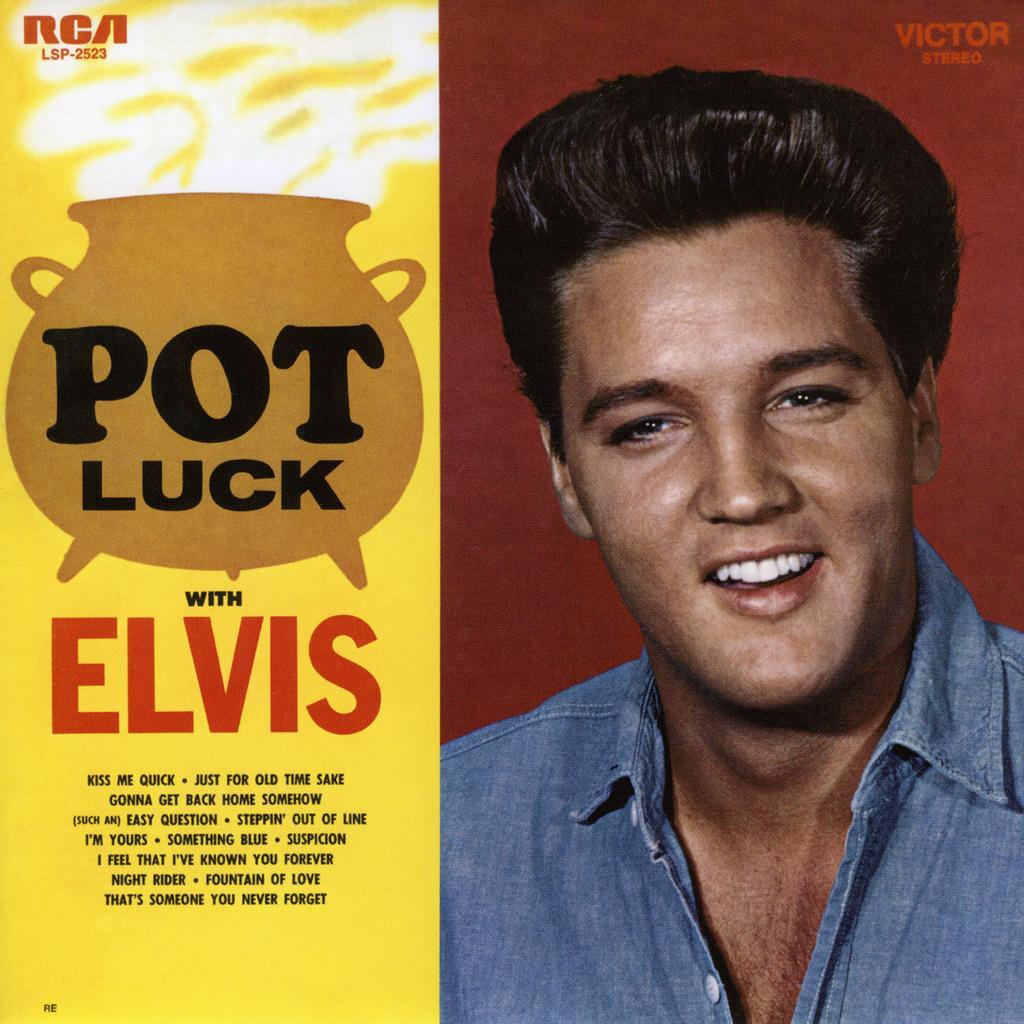Could you give a brief overview of what you see in this image? In this image we can see an edited picture of a person with some text on it. 